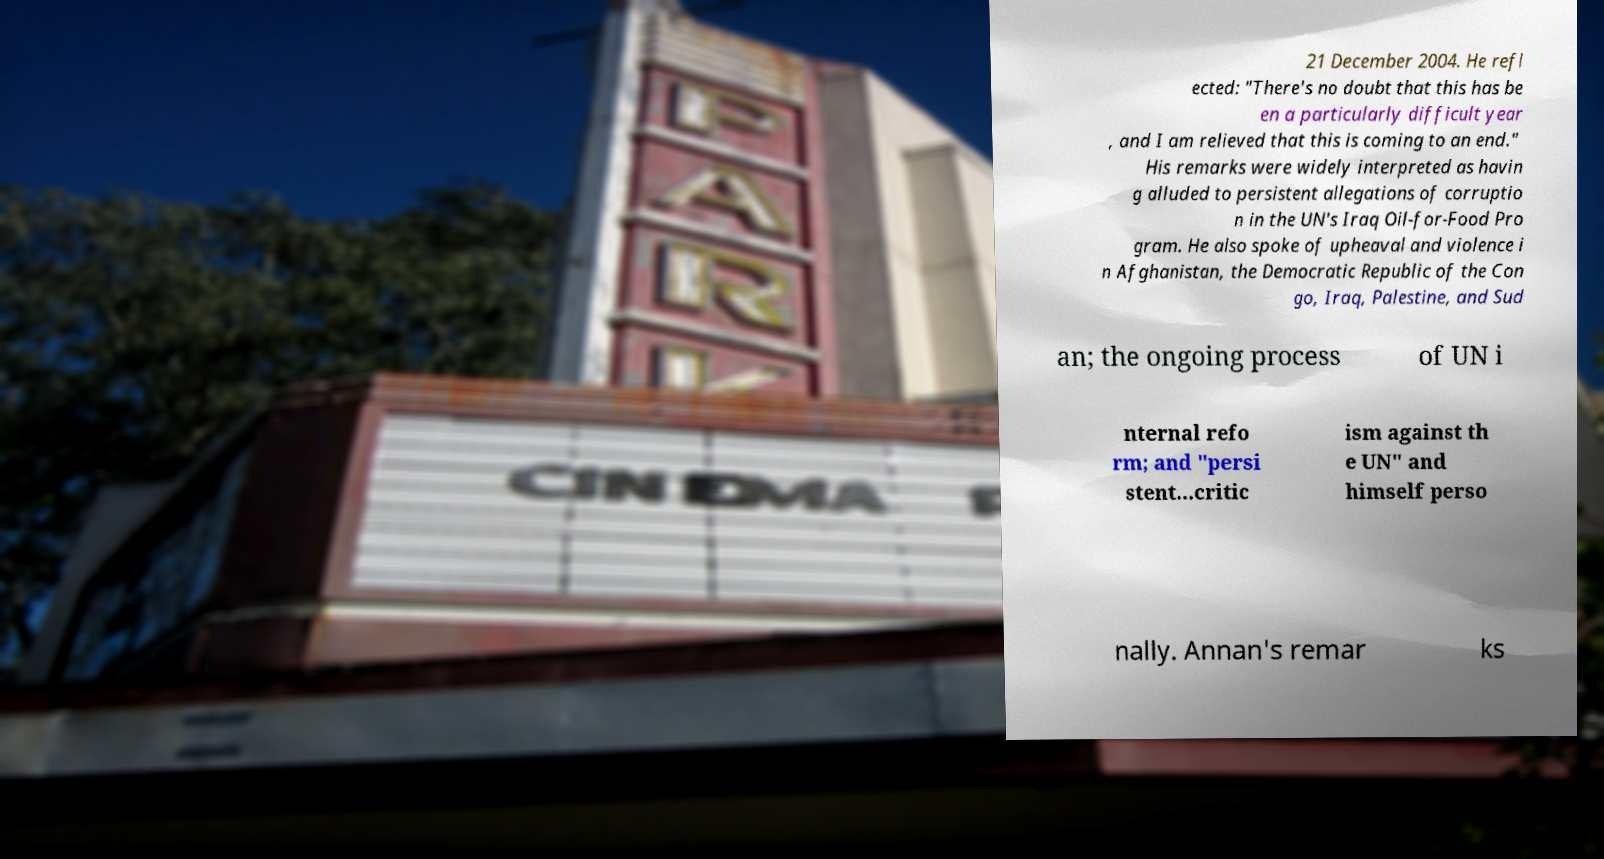Please read and relay the text visible in this image. What does it say? 21 December 2004. He refl ected: "There's no doubt that this has be en a particularly difficult year , and I am relieved that this is coming to an end." His remarks were widely interpreted as havin g alluded to persistent allegations of corruptio n in the UN's Iraq Oil-for-Food Pro gram. He also spoke of upheaval and violence i n Afghanistan, the Democratic Republic of the Con go, Iraq, Palestine, and Sud an; the ongoing process of UN i nternal refo rm; and "persi stent...critic ism against th e UN" and himself perso nally. Annan's remar ks 